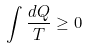<formula> <loc_0><loc_0><loc_500><loc_500>\int \frac { d Q } { T } \geq 0</formula> 